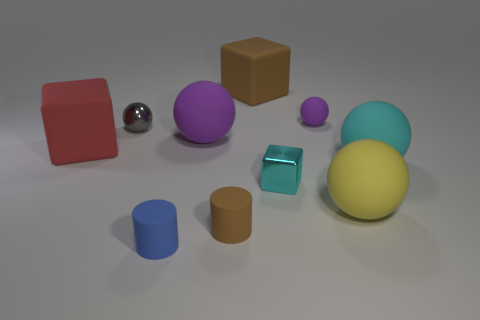Subtract all big matte cubes. How many cubes are left? 1 Subtract all blue cubes. How many purple balls are left? 2 Subtract all cyan cubes. How many cubes are left? 2 Subtract all cylinders. How many objects are left? 8 Subtract all big yellow things. Subtract all big cyan balls. How many objects are left? 8 Add 7 tiny brown rubber objects. How many tiny brown rubber objects are left? 8 Add 5 small blue things. How many small blue things exist? 6 Subtract 1 gray balls. How many objects are left? 9 Subtract 1 balls. How many balls are left? 4 Subtract all yellow cylinders. Subtract all green spheres. How many cylinders are left? 2 